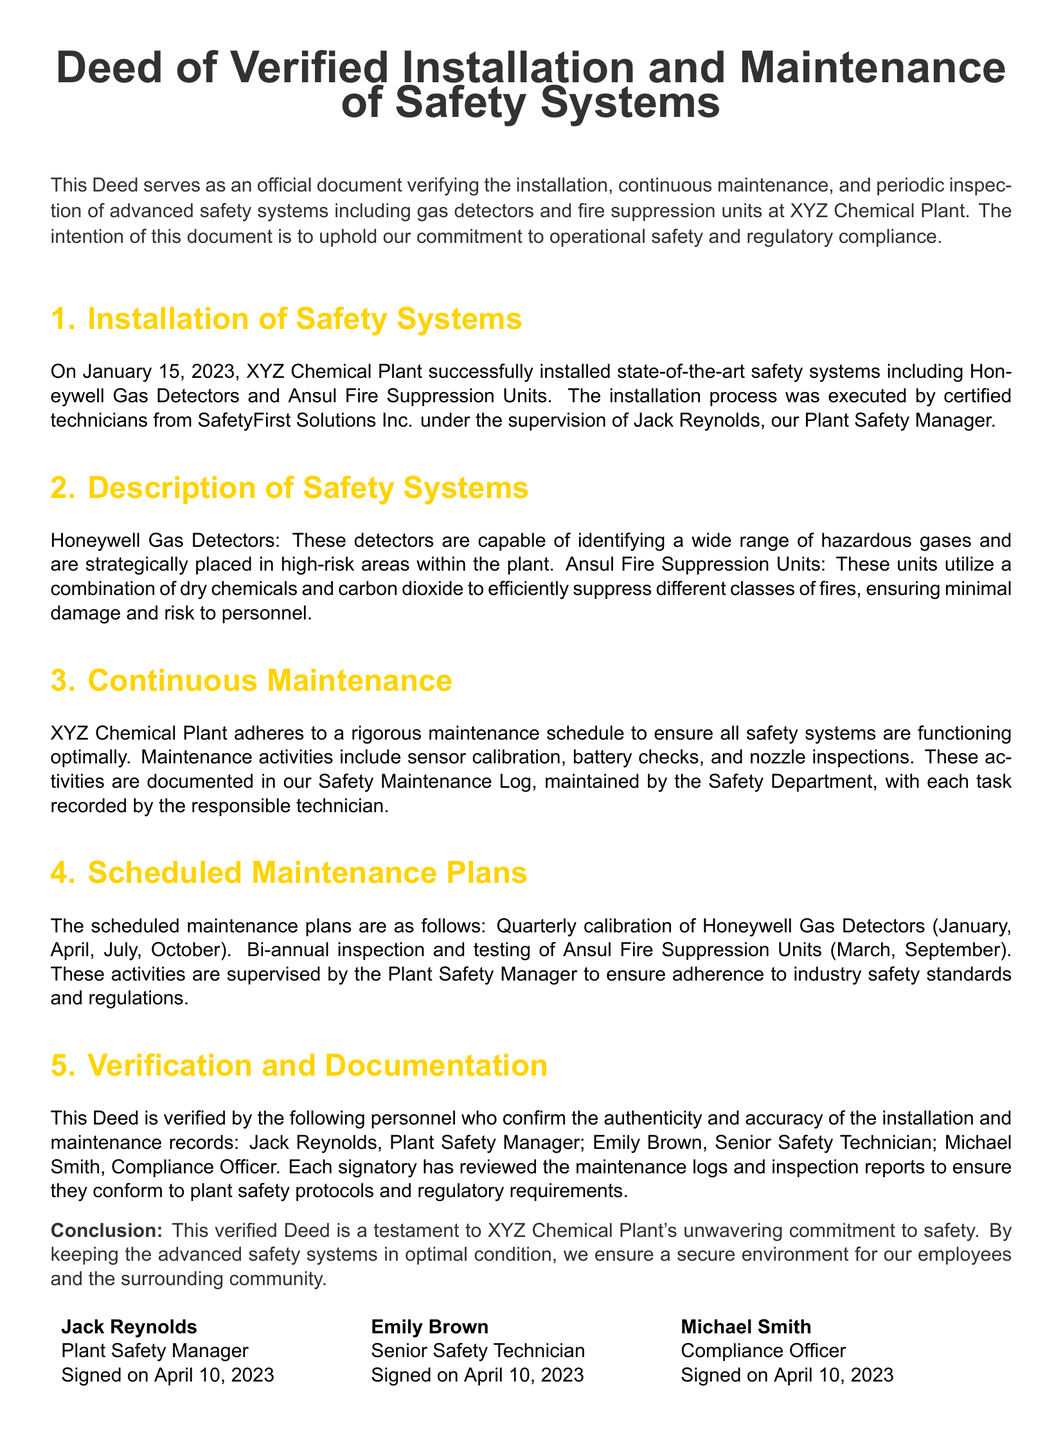What date was the installation completed? The installation was completed on January 15, 2023, as stated in the document.
Answer: January 15, 2023 Who supervised the installation of the safety systems? The supervisor mentioned in the document is Jack Reynolds, the Plant Safety Manager.
Answer: Jack Reynolds What type of gas detectors were installed? The document specifies that Honeywell Gas Detectors were installed at the plant.
Answer: Honeywell Gas Detectors How often are the gas detectors calibrated? The maintenance schedule states that calibration occurs quarterly, specifically in January, April, July, and October.
Answer: Quarterly Who is responsible for maintaining the Safety Maintenance Log? The document mentions that the Safety Department maintains the Safety Maintenance Log.
Answer: Safety Department What are the fire suppression units mentioned? The fire suppression units are identified as Ansul Fire Suppression Units in the document.
Answer: Ansul Fire Suppression Units Which personnel verified the authenticity of the deed? The verifiers listed in the document include Jack Reynolds, Emily Brown, and Michael Smith.
Answer: Jack Reynolds, Emily Brown, Michael Smith How many inspections of the fire suppression units are scheduled annually? The document states that the inspections of the fire suppression units occur bi-annually, which amounts to two inspections a year.
Answer: Two What is the purpose of this Deed? The purpose is to verify the installation and maintenance of safety systems and ensure operational safety and regulatory compliance.
Answer: Ensure operational safety and regulatory compliance 